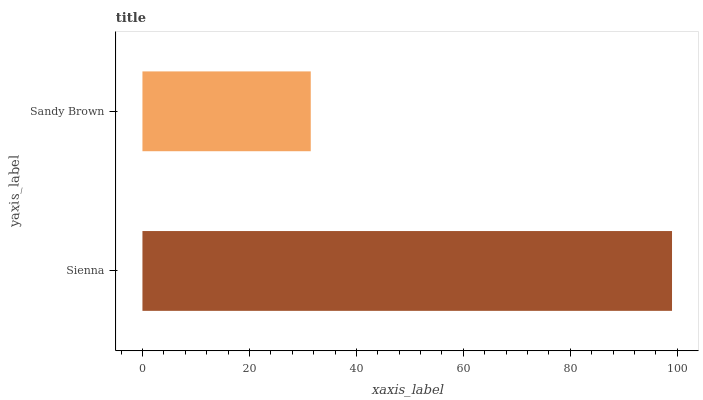Is Sandy Brown the minimum?
Answer yes or no. Yes. Is Sienna the maximum?
Answer yes or no. Yes. Is Sandy Brown the maximum?
Answer yes or no. No. Is Sienna greater than Sandy Brown?
Answer yes or no. Yes. Is Sandy Brown less than Sienna?
Answer yes or no. Yes. Is Sandy Brown greater than Sienna?
Answer yes or no. No. Is Sienna less than Sandy Brown?
Answer yes or no. No. Is Sienna the high median?
Answer yes or no. Yes. Is Sandy Brown the low median?
Answer yes or no. Yes. Is Sandy Brown the high median?
Answer yes or no. No. Is Sienna the low median?
Answer yes or no. No. 